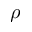<formula> <loc_0><loc_0><loc_500><loc_500>\rho</formula> 